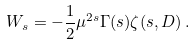Convert formula to latex. <formula><loc_0><loc_0><loc_500><loc_500>W _ { s } = - \frac { 1 } { 2 } \mu ^ { 2 s } \Gamma ( s ) \zeta ( s , D ) \, .</formula> 